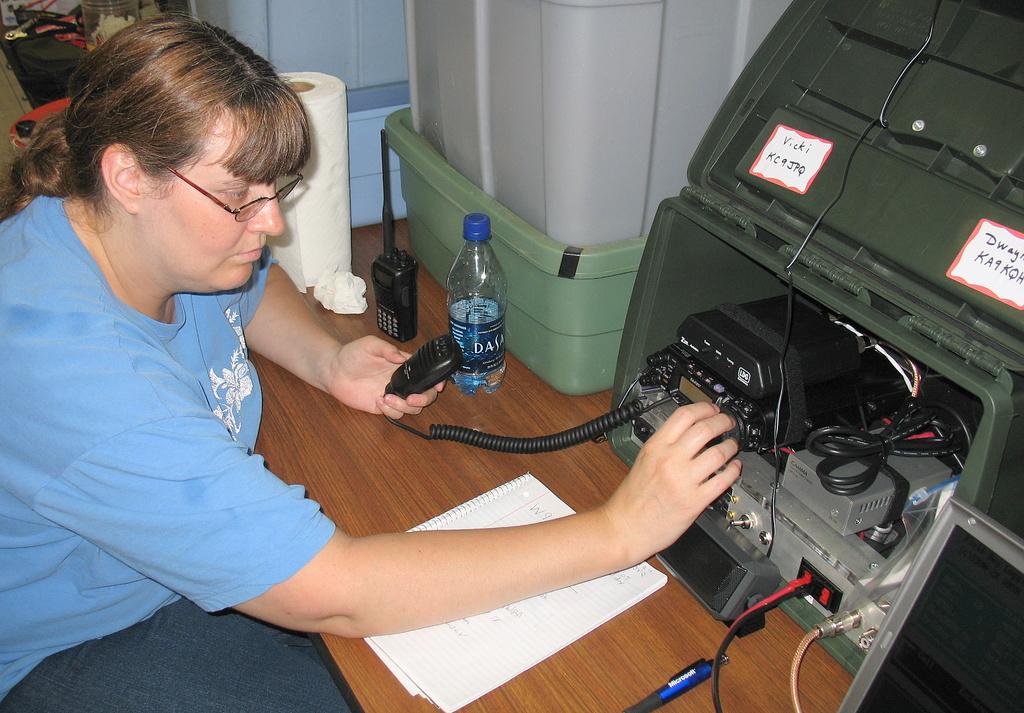What is written on the water bottle?
Offer a very short reply. Dasani. 